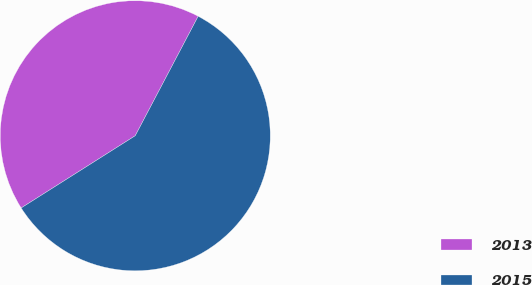<chart> <loc_0><loc_0><loc_500><loc_500><pie_chart><fcel>2013<fcel>2015<nl><fcel>41.7%<fcel>58.3%<nl></chart> 